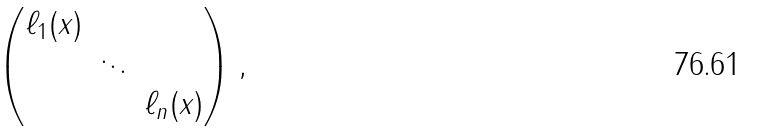<formula> <loc_0><loc_0><loc_500><loc_500>\begin{pmatrix} \ell _ { 1 } ( x ) & & \\ & \ddots & \\ & & \ell _ { n } ( x ) \end{pmatrix} ,</formula> 